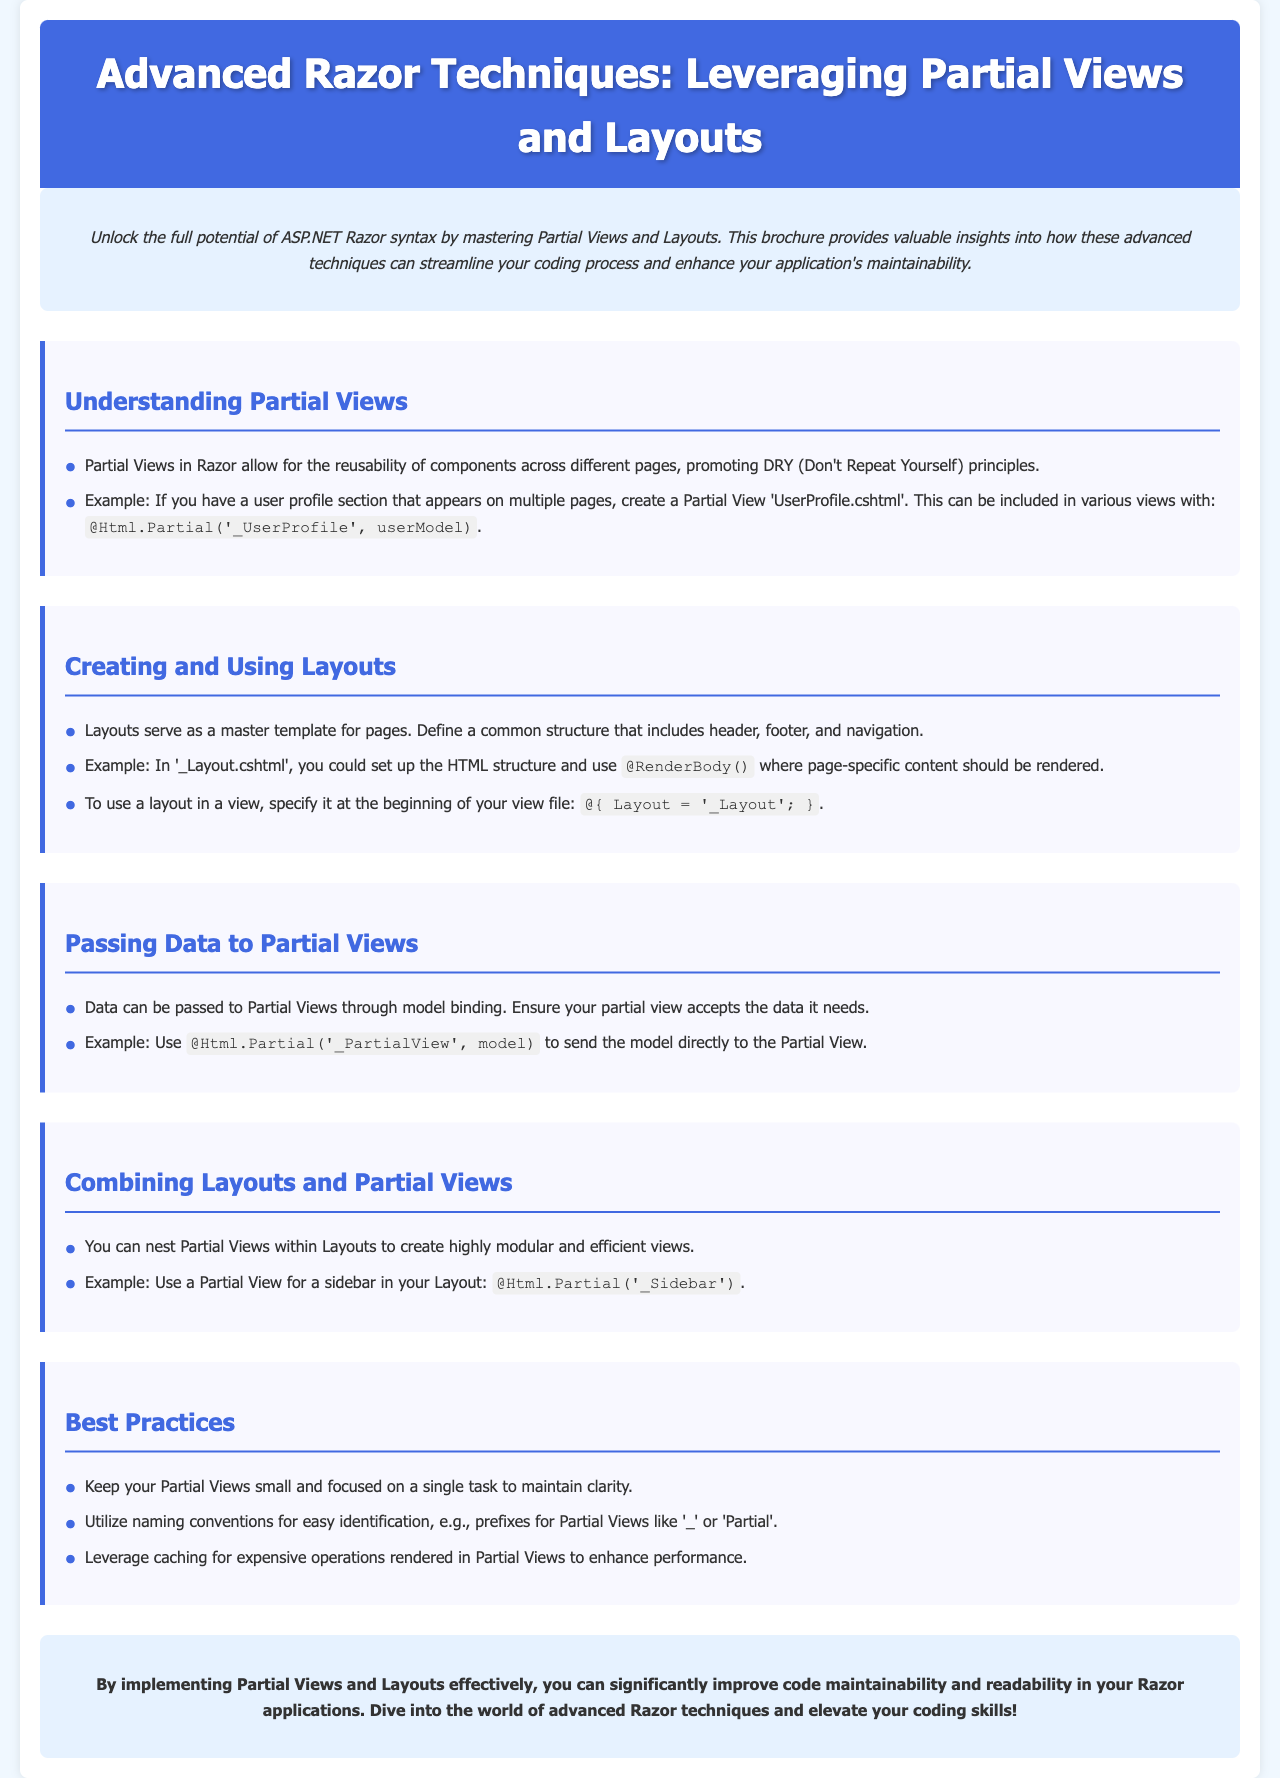What is the title of the brochure? The title is prominently displayed in the header section as the main theme of the document.
Answer: Advanced Razor Techniques: Leveraging Partial Views and Layouts What is the main benefit of using Partial Views? The document states that Partial Views promote DRY (Don't Repeat Yourself) principles, which is a key benefit.
Answer: Reusability What is the HTML structure used to include a Partial View? The document provides a clear example of how to include a Partial View in Razor syntax.
Answer: @Html.Partial('_UserProfile', userModel) What should be specified at the beginning of a view file to use a layout? The document discusses the necessary syntax to reference a layout at the start of a view.
Answer: @{ Layout = '_Layout'; } What is a recommended size for Partial Views to maintain clarity? The document suggests keeping Partial Views focused for better maintainability.
Answer: Small Which color is used for the header background? The document specifies the design elements, including color choices used in the header section.
Answer: Royal Blue What technique is recommended to enhance performance in Partial Views? The document mentions a strategy to improve efficiency when using Partial Views.
Answer: Caching How should names for Partial Views be prefixed? The document advises on a naming convention for better identification.
Answer: Underscore What is the purpose of Layouts in Razor? The document describes Layouts as serving a specific function in the structure of web pages.
Answer: Master template 